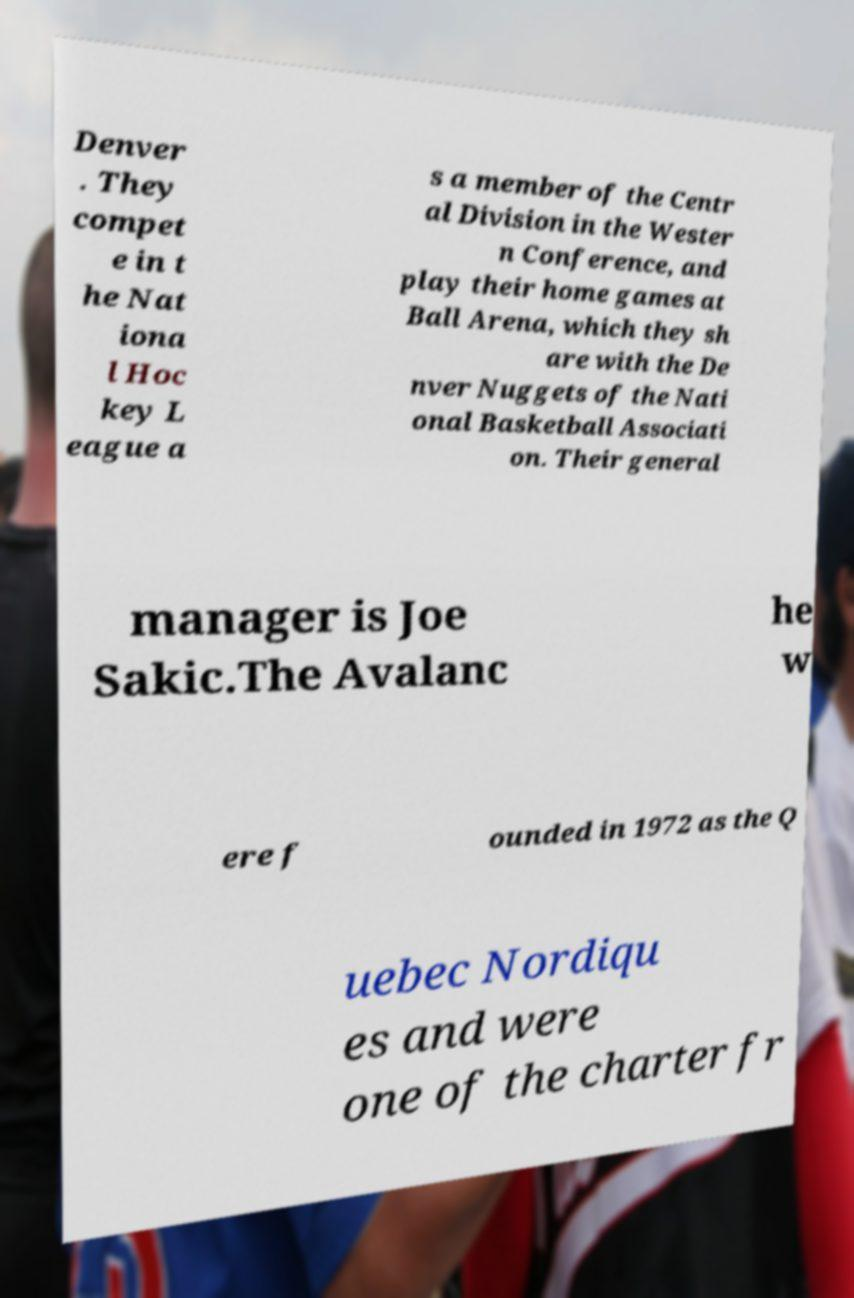Could you extract and type out the text from this image? Denver . They compet e in t he Nat iona l Hoc key L eague a s a member of the Centr al Division in the Wester n Conference, and play their home games at Ball Arena, which they sh are with the De nver Nuggets of the Nati onal Basketball Associati on. Their general manager is Joe Sakic.The Avalanc he w ere f ounded in 1972 as the Q uebec Nordiqu es and were one of the charter fr 